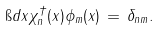<formula> <loc_0><loc_0><loc_500><loc_500>\i d x \chi ^ { \dagger } _ { n } ( x ) \phi _ { m } ( x ) \, = \, \delta _ { n m } .</formula> 